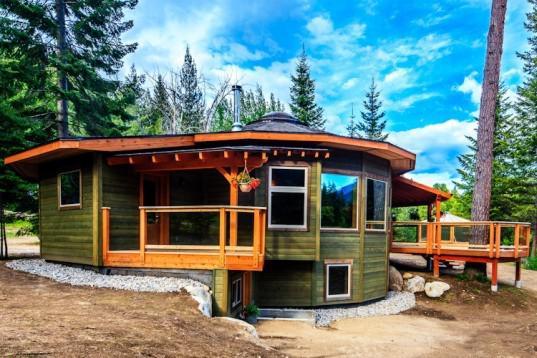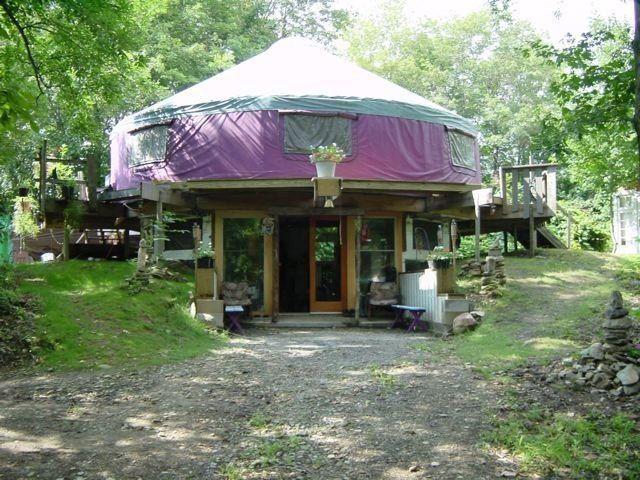The first image is the image on the left, the second image is the image on the right. For the images displayed, is the sentence "Each of two yurts has two distinct levels and one or more fenced wooden deck sections." factually correct? Answer yes or no. Yes. The first image is the image on the left, the second image is the image on the right. For the images displayed, is the sentence "An image shows a round house with a railing above two white garage doors." factually correct? Answer yes or no. No. 